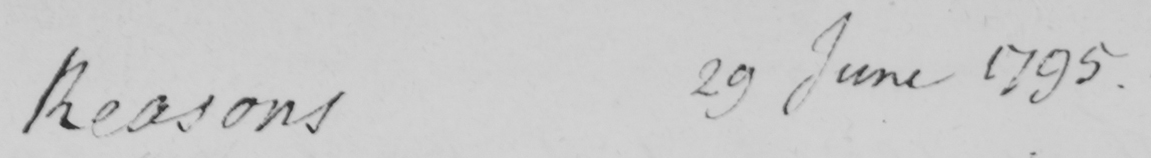Transcribe the text shown in this historical manuscript line. Reasons 29 June 1795 . 